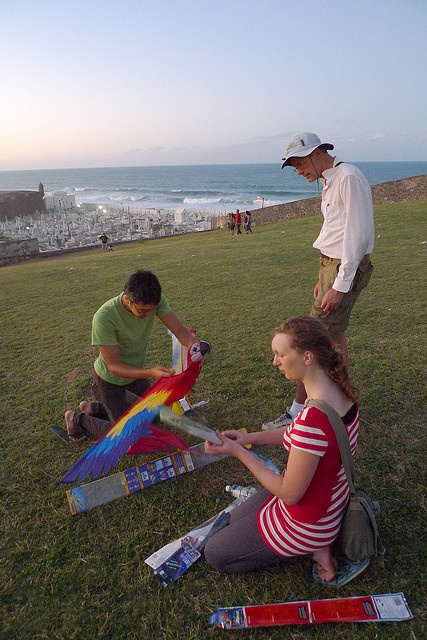Describe the objects in this image and their specific colors. I can see people in lavender, maroon, brown, black, and gray tones, people in lavender, black, darkgreen, maroon, and gray tones, people in lavender, darkgray, black, maroon, and lightgray tones, kite in lavender, navy, maroon, blue, and brown tones, and backpack in lavender, black, and gray tones in this image. 